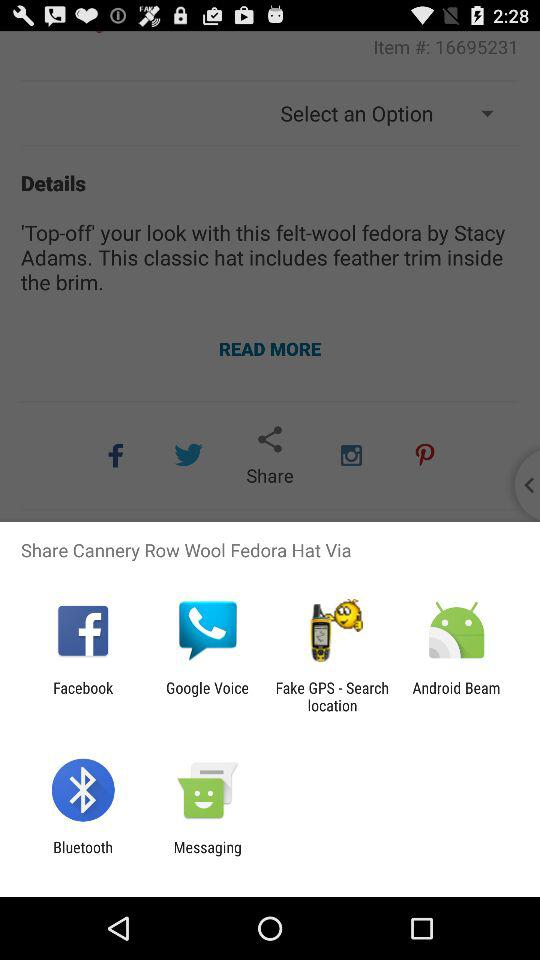Who designed Wool fedora?
When the provided information is insufficient, respond with <no answer>. <no answer> 